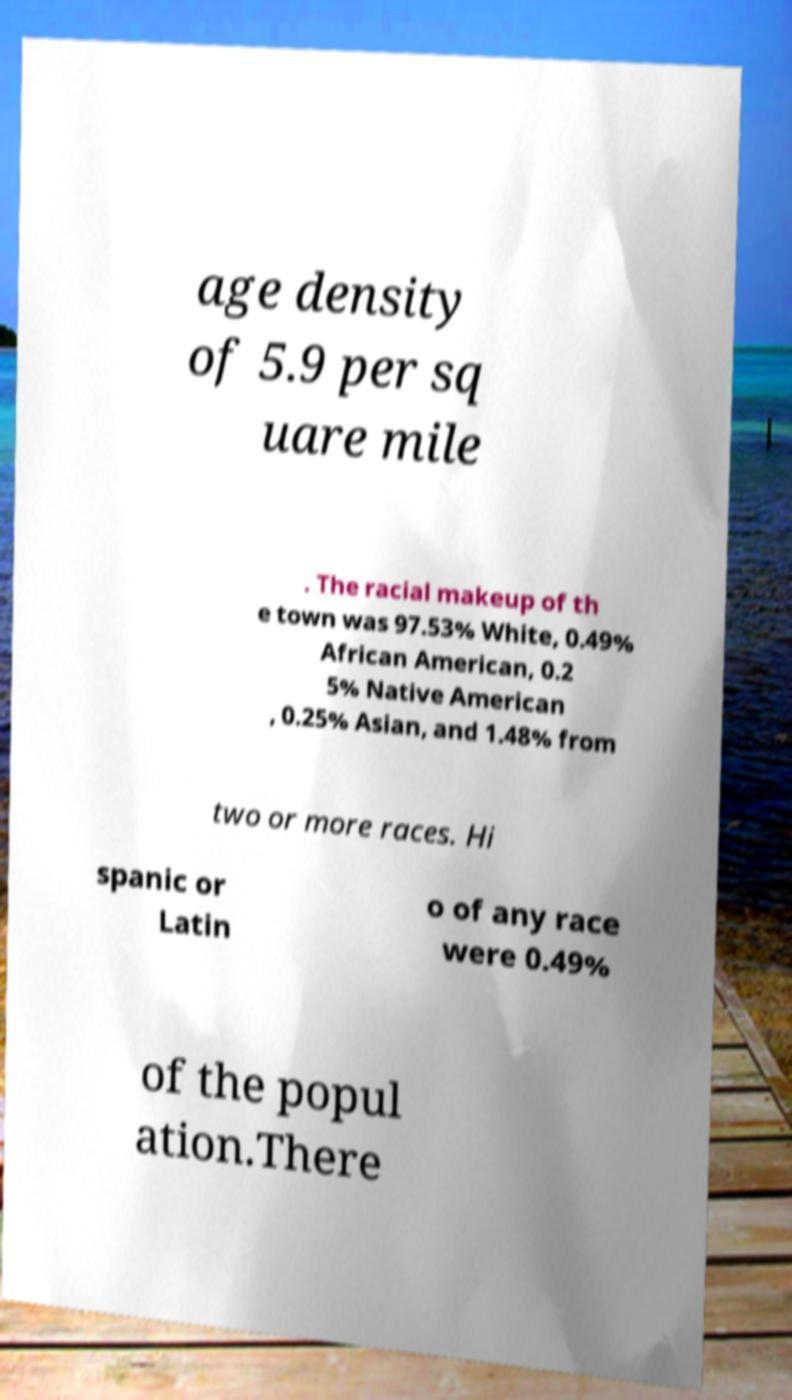What messages or text are displayed in this image? I need them in a readable, typed format. age density of 5.9 per sq uare mile . The racial makeup of th e town was 97.53% White, 0.49% African American, 0.2 5% Native American , 0.25% Asian, and 1.48% from two or more races. Hi spanic or Latin o of any race were 0.49% of the popul ation.There 